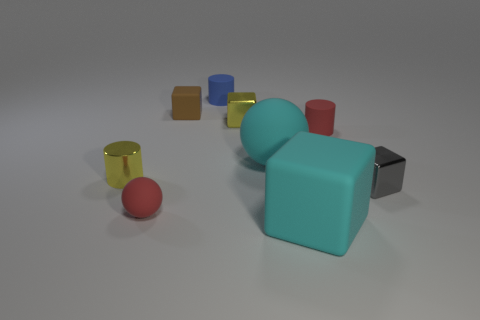Is there a pattern or theme in the arrangement of the objects? The objects seem to be arranged somewhat randomly without a clear pattern. However, there is a visual balance created by the varying sizes and colors that provides a pleasing aesthetic to the scene. It's possible that the arrangement is meant to provide a study in contrast—smooth versus matte surfaces, geometric shapes, and a spectrum of colors. 